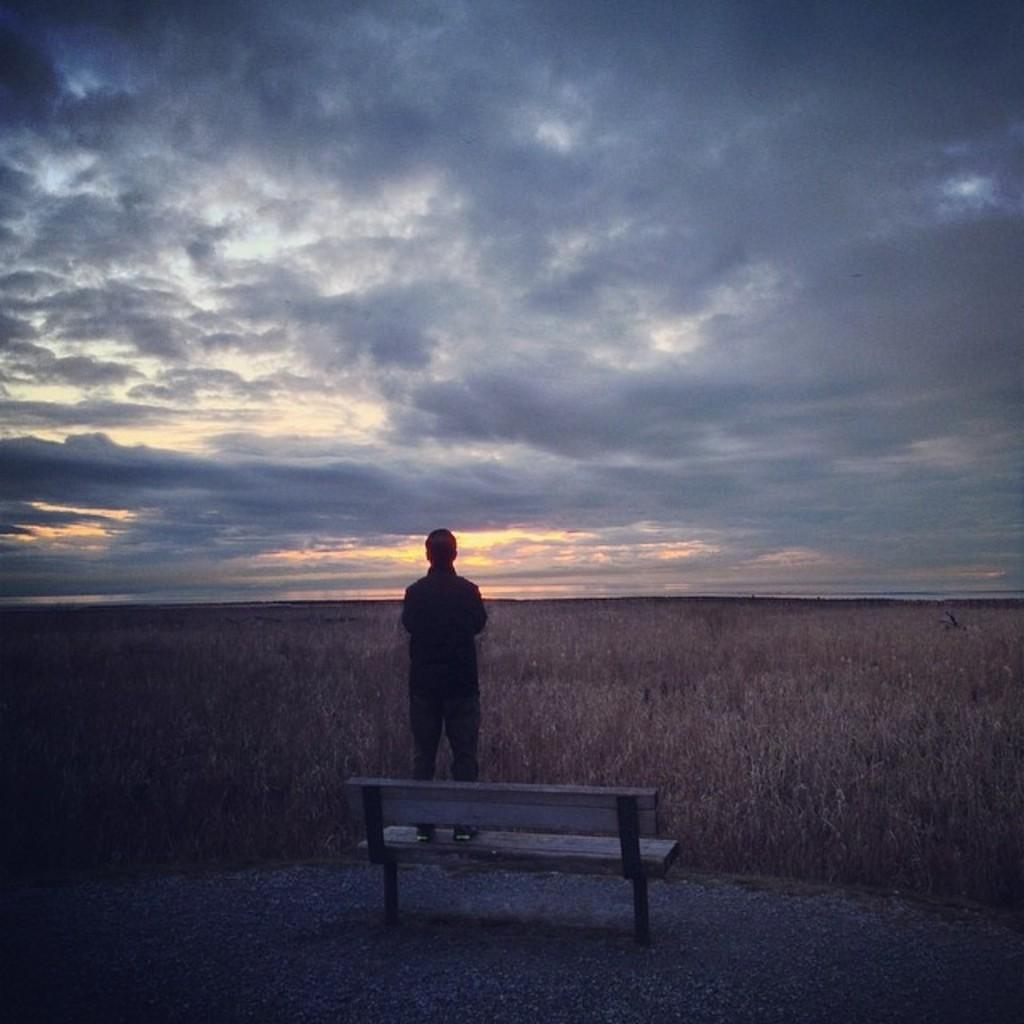What is the person in the image doing? The person is standing on a bench in the image. What can be seen in the background of the image? There are plants in the background of the image. What is visible above the plants and the person? The sky is visible in the image. What can be observed in the sky? Clouds are present in the sky. Where is the ant located in the image? There is no ant present in the image. What time does the clock show in the image? There is no clock present in the image. 